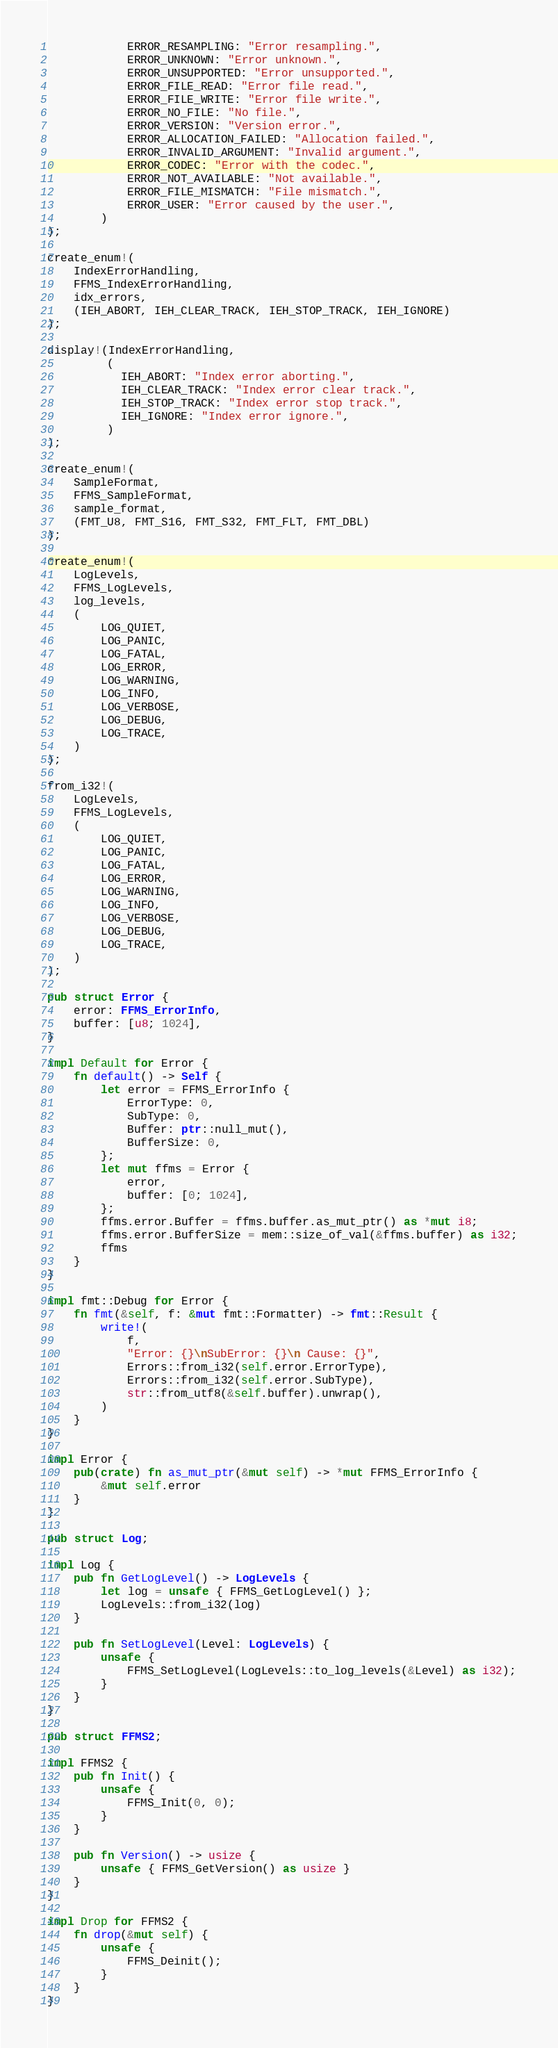<code> <loc_0><loc_0><loc_500><loc_500><_Rust_>            ERROR_RESAMPLING: "Error resampling.",
            ERROR_UNKNOWN: "Error unknown.",
            ERROR_UNSUPPORTED: "Error unsupported.",
            ERROR_FILE_READ: "Error file read.",
            ERROR_FILE_WRITE: "Error file write.",
            ERROR_NO_FILE: "No file.",
            ERROR_VERSION: "Version error.",
            ERROR_ALLOCATION_FAILED: "Allocation failed.",
            ERROR_INVALID_ARGUMENT: "Invalid argument.",
            ERROR_CODEC: "Error with the codec.",
            ERROR_NOT_AVAILABLE: "Not available.",
            ERROR_FILE_MISMATCH: "File mismatch.",
            ERROR_USER: "Error caused by the user.",
        )
);

create_enum!(
    IndexErrorHandling,
    FFMS_IndexErrorHandling,
    idx_errors,
    (IEH_ABORT, IEH_CLEAR_TRACK, IEH_STOP_TRACK, IEH_IGNORE)
);

display!(IndexErrorHandling,
         (
           IEH_ABORT: "Index error aborting.",
           IEH_CLEAR_TRACK: "Index error clear track.",
           IEH_STOP_TRACK: "Index error stop track.",
           IEH_IGNORE: "Index error ignore.",
         )
);

create_enum!(
    SampleFormat,
    FFMS_SampleFormat,
    sample_format,
    (FMT_U8, FMT_S16, FMT_S32, FMT_FLT, FMT_DBL)
);

create_enum!(
    LogLevels,
    FFMS_LogLevels,
    log_levels,
    (
        LOG_QUIET,
        LOG_PANIC,
        LOG_FATAL,
        LOG_ERROR,
        LOG_WARNING,
        LOG_INFO,
        LOG_VERBOSE,
        LOG_DEBUG,
        LOG_TRACE,
    )
);

from_i32!(
    LogLevels,
    FFMS_LogLevels,
    (
        LOG_QUIET,
        LOG_PANIC,
        LOG_FATAL,
        LOG_ERROR,
        LOG_WARNING,
        LOG_INFO,
        LOG_VERBOSE,
        LOG_DEBUG,
        LOG_TRACE,
    )
);

pub struct Error {
    error: FFMS_ErrorInfo,
    buffer: [u8; 1024],
}

impl Default for Error {
    fn default() -> Self {
        let error = FFMS_ErrorInfo {
            ErrorType: 0,
            SubType: 0,
            Buffer: ptr::null_mut(),
            BufferSize: 0,
        };
        let mut ffms = Error {
            error,
            buffer: [0; 1024],
        };
        ffms.error.Buffer = ffms.buffer.as_mut_ptr() as *mut i8;
        ffms.error.BufferSize = mem::size_of_val(&ffms.buffer) as i32;
        ffms
    }
}

impl fmt::Debug for Error {
    fn fmt(&self, f: &mut fmt::Formatter) -> fmt::Result {
        write!(
            f,
            "Error: {}\nSubError: {}\n Cause: {}",
            Errors::from_i32(self.error.ErrorType),
            Errors::from_i32(self.error.SubType),
            str::from_utf8(&self.buffer).unwrap(),
        )
    }
}

impl Error {
    pub(crate) fn as_mut_ptr(&mut self) -> *mut FFMS_ErrorInfo {
        &mut self.error
    }
}

pub struct Log;

impl Log {
    pub fn GetLogLevel() -> LogLevels {
        let log = unsafe { FFMS_GetLogLevel() };
        LogLevels::from_i32(log)
    }

    pub fn SetLogLevel(Level: LogLevels) {
        unsafe {
            FFMS_SetLogLevel(LogLevels::to_log_levels(&Level) as i32);
        }
    }
}

pub struct FFMS2;

impl FFMS2 {
    pub fn Init() {
        unsafe {
            FFMS_Init(0, 0);
        }
    }

    pub fn Version() -> usize {
        unsafe { FFMS_GetVersion() as usize }
    }
}

impl Drop for FFMS2 {
    fn drop(&mut self) {
        unsafe {
            FFMS_Deinit();
        }
    }
}
</code> 